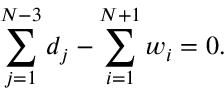Convert formula to latex. <formula><loc_0><loc_0><loc_500><loc_500>\sum _ { j = 1 } ^ { N - 3 } d _ { j } - \sum _ { i = 1 } ^ { N + 1 } w _ { i } = 0 .</formula> 